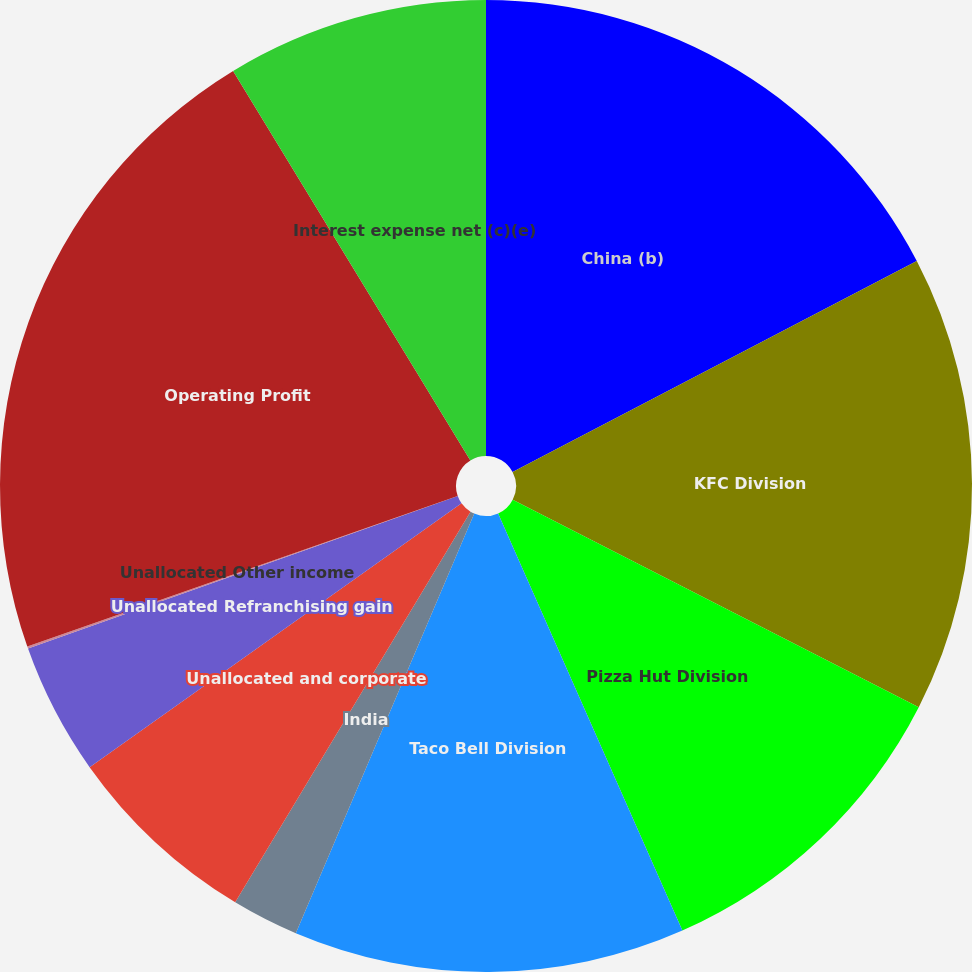<chart> <loc_0><loc_0><loc_500><loc_500><pie_chart><fcel>China (b)<fcel>KFC Division<fcel>Pizza Hut Division<fcel>Taco Bell Division<fcel>India<fcel>Unallocated and corporate<fcel>Unallocated Refranchising gain<fcel>Unallocated Other income<fcel>Operating Profit<fcel>Interest expense net (c)(e)<nl><fcel>17.34%<fcel>15.18%<fcel>10.86%<fcel>13.02%<fcel>2.23%<fcel>6.55%<fcel>4.39%<fcel>0.07%<fcel>21.65%<fcel>8.71%<nl></chart> 